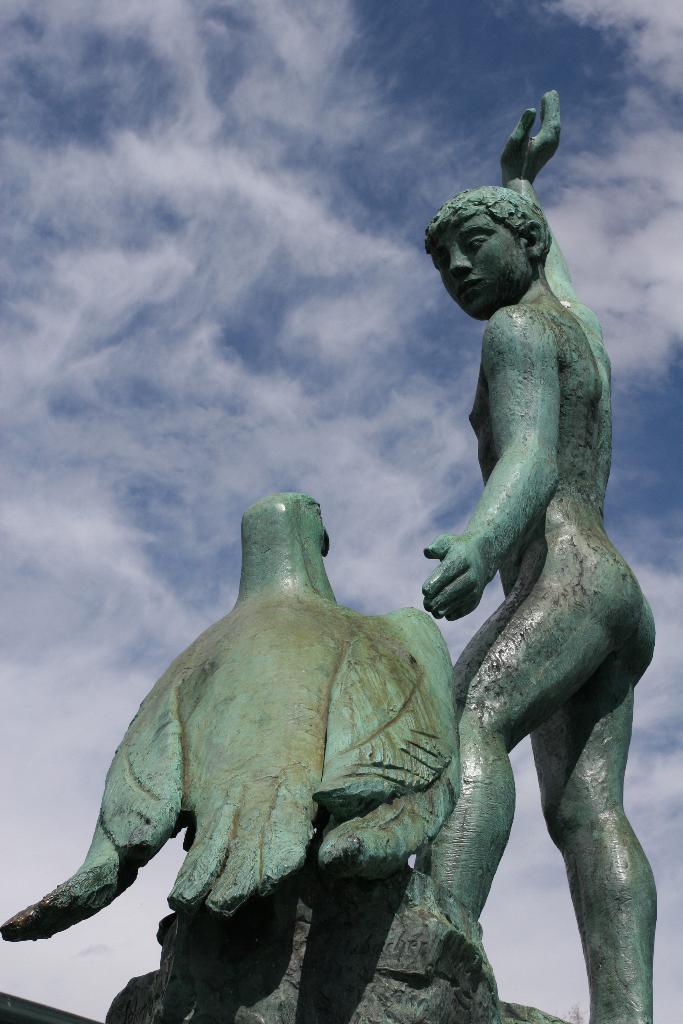Could you give a brief overview of what you see in this image? In this picture I can see statue of a man and a bird and I can see a blue cloudy sky. 